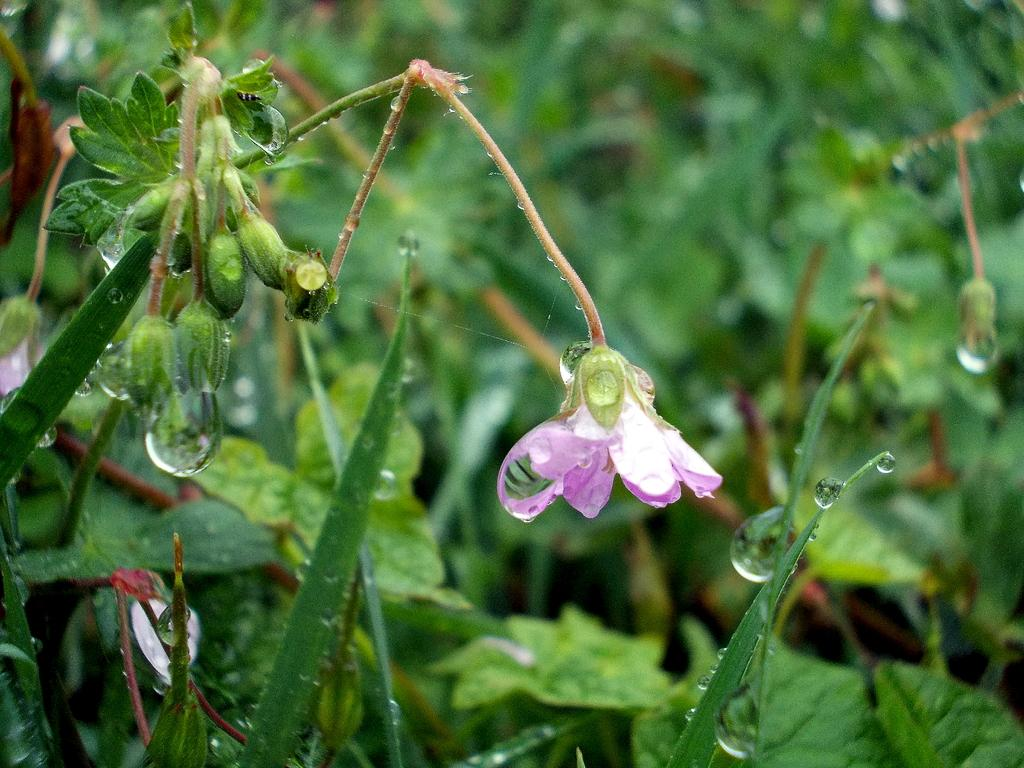What type of living organisms can be seen in the image? Plants can be seen in the image. Can you describe a specific flower in the image? There is a purple flower in the image. What stage of growth are some of the plants in the image? There are buds in the image, indicating that some plants are in the early stages of growth. What is the condition of the leaves in the image? There are water droplets on the leaves in the image. What type of cloth is being used to transport the plants in the image? There is no cloth or transportation of plants visible in the image. 